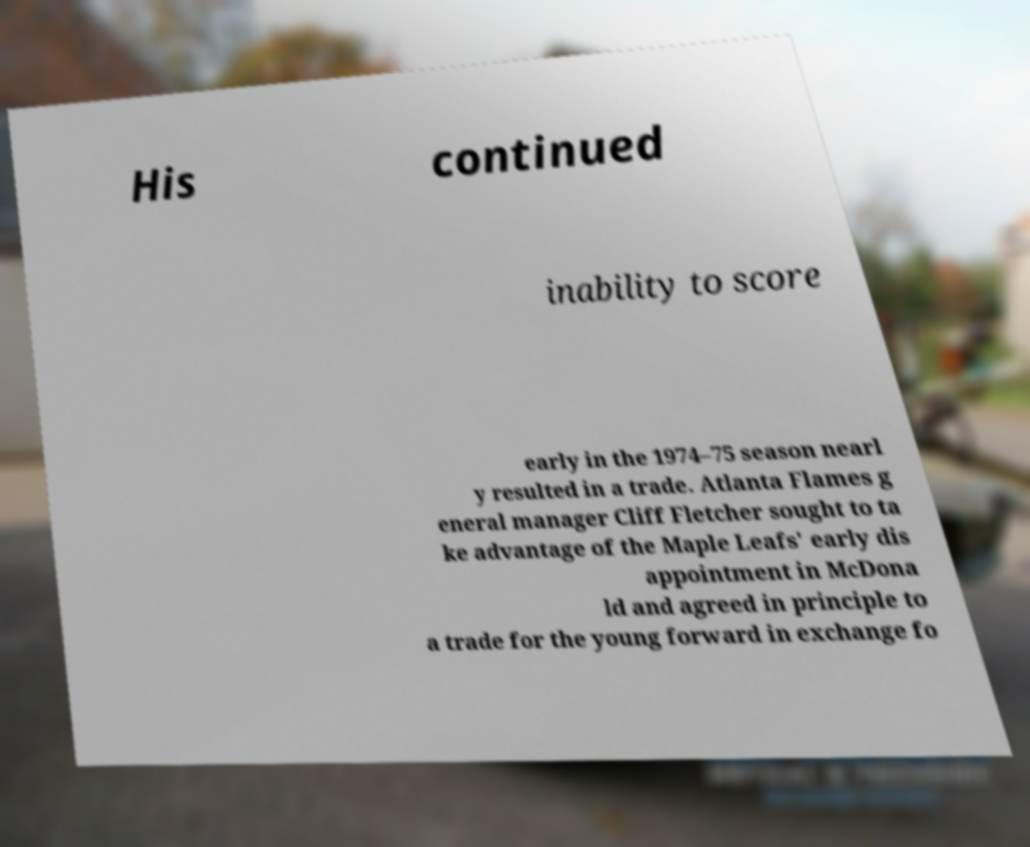Can you read and provide the text displayed in the image?This photo seems to have some interesting text. Can you extract and type it out for me? His continued inability to score early in the 1974–75 season nearl y resulted in a trade. Atlanta Flames g eneral manager Cliff Fletcher sought to ta ke advantage of the Maple Leafs' early dis appointment in McDona ld and agreed in principle to a trade for the young forward in exchange fo 